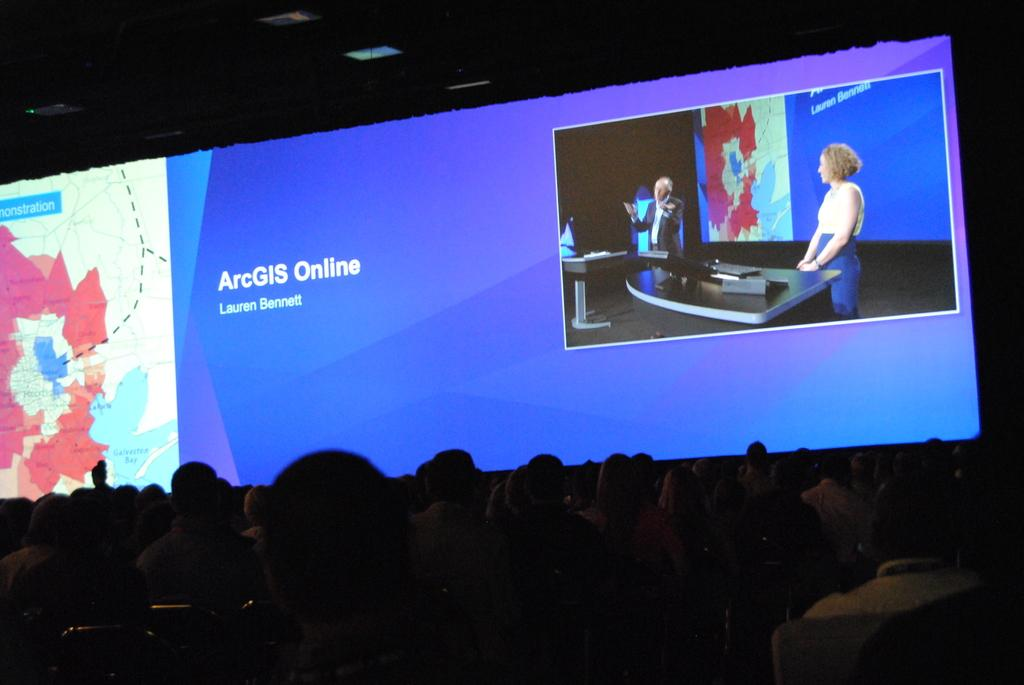Provide a one-sentence caption for the provided image. A screen displayed before an audience has the text "ArcGIS Online" on it. 